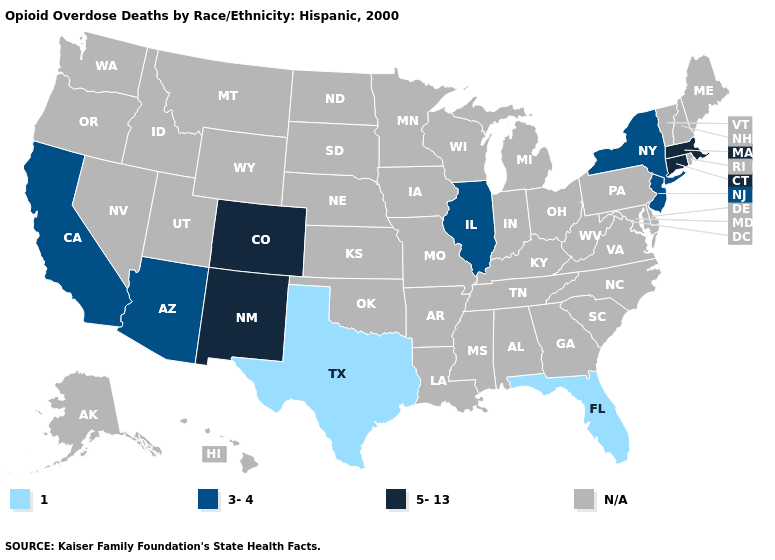What is the value of New Jersey?
Concise answer only. 3-4. What is the lowest value in the Northeast?
Short answer required. 3-4. Is the legend a continuous bar?
Short answer required. No. Does New York have the lowest value in the Northeast?
Give a very brief answer. Yes. Among the states that border Oklahoma , does Texas have the lowest value?
Be succinct. Yes. What is the value of New Jersey?
Answer briefly. 3-4. What is the lowest value in the South?
Write a very short answer. 1. Name the states that have a value in the range N/A?
Concise answer only. Alabama, Alaska, Arkansas, Delaware, Georgia, Hawaii, Idaho, Indiana, Iowa, Kansas, Kentucky, Louisiana, Maine, Maryland, Michigan, Minnesota, Mississippi, Missouri, Montana, Nebraska, Nevada, New Hampshire, North Carolina, North Dakota, Ohio, Oklahoma, Oregon, Pennsylvania, Rhode Island, South Carolina, South Dakota, Tennessee, Utah, Vermont, Virginia, Washington, West Virginia, Wisconsin, Wyoming. What is the value of Indiana?
Short answer required. N/A. Among the states that border Georgia , which have the lowest value?
Short answer required. Florida. Name the states that have a value in the range 1?
Concise answer only. Florida, Texas. Name the states that have a value in the range 3-4?
Concise answer only. Arizona, California, Illinois, New Jersey, New York. 